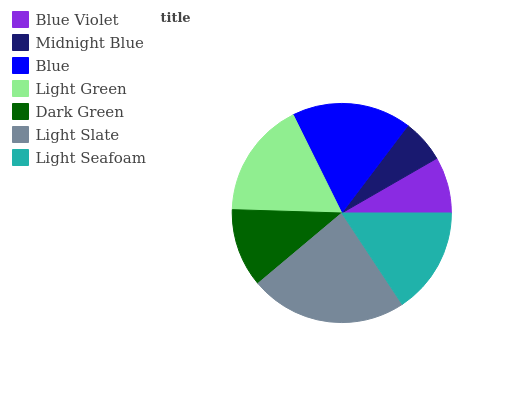Is Midnight Blue the minimum?
Answer yes or no. Yes. Is Light Slate the maximum?
Answer yes or no. Yes. Is Blue the minimum?
Answer yes or no. No. Is Blue the maximum?
Answer yes or no. No. Is Blue greater than Midnight Blue?
Answer yes or no. Yes. Is Midnight Blue less than Blue?
Answer yes or no. Yes. Is Midnight Blue greater than Blue?
Answer yes or no. No. Is Blue less than Midnight Blue?
Answer yes or no. No. Is Light Seafoam the high median?
Answer yes or no. Yes. Is Light Seafoam the low median?
Answer yes or no. Yes. Is Light Slate the high median?
Answer yes or no. No. Is Midnight Blue the low median?
Answer yes or no. No. 